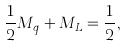<formula> <loc_0><loc_0><loc_500><loc_500>\frac { 1 } { 2 } M _ { q } + M _ { L } = \frac { 1 } { 2 } ,</formula> 